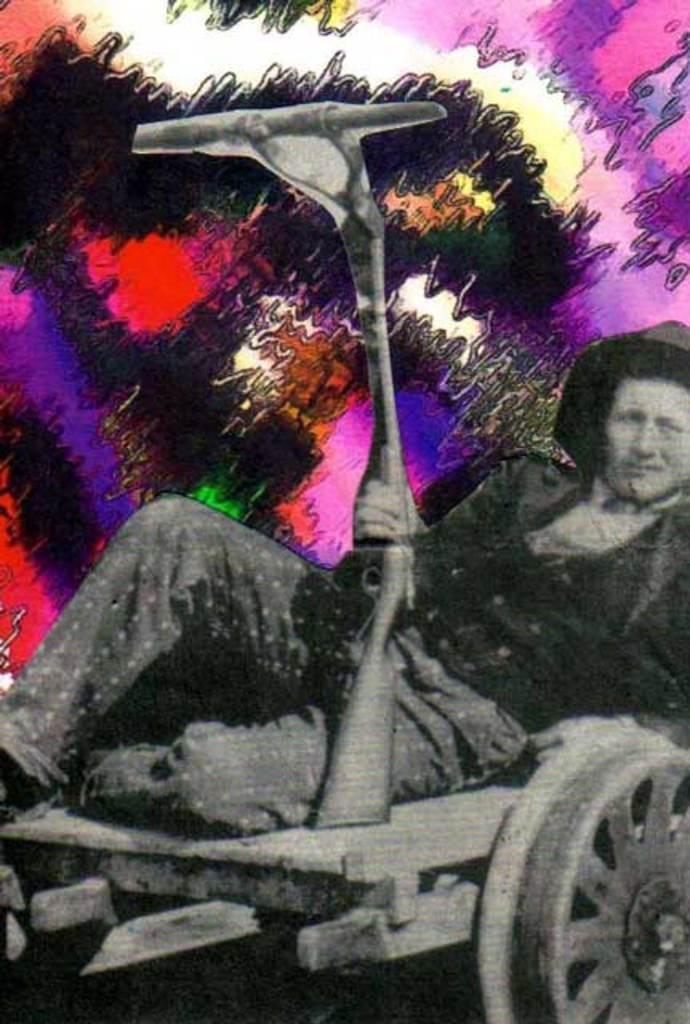What is the main subject of the image? There is a person in the image. What is the person doing in the image? The person is laying on a vehicle. What object is the person holding in the image? The person is holding a gun. What shape is the person's father in the image? There is no mention of a father or any shapes in the image. 